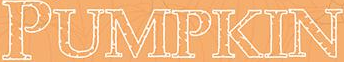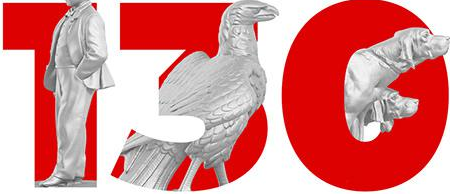What text is displayed in these images sequentially, separated by a semicolon? PUMPKIN; 130 